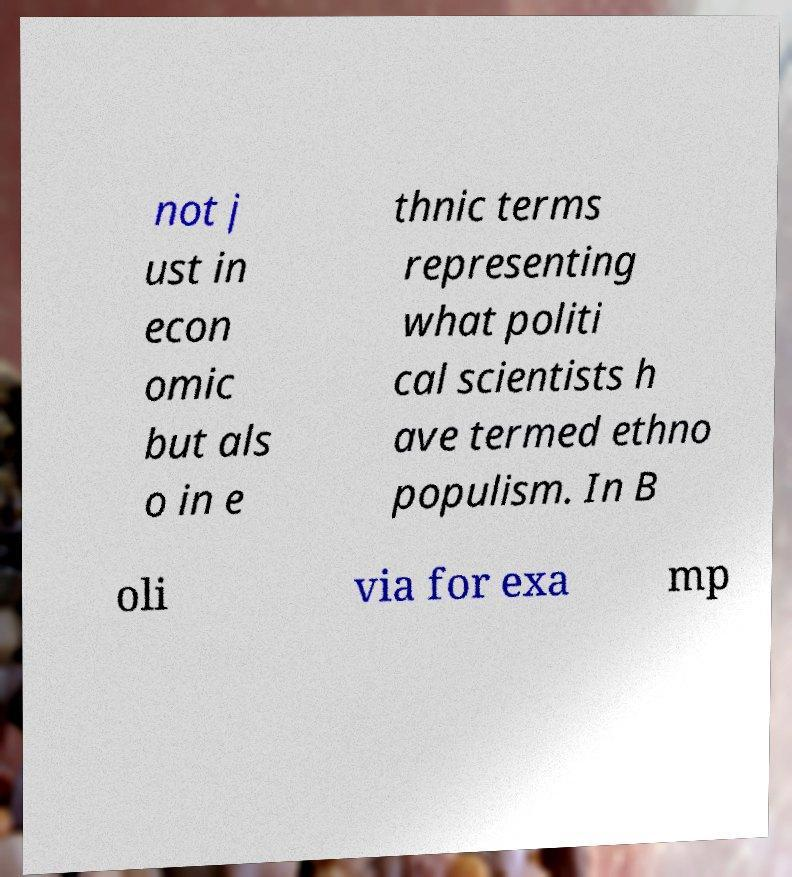Can you read and provide the text displayed in the image?This photo seems to have some interesting text. Can you extract and type it out for me? not j ust in econ omic but als o in e thnic terms representing what politi cal scientists h ave termed ethno populism. In B oli via for exa mp 